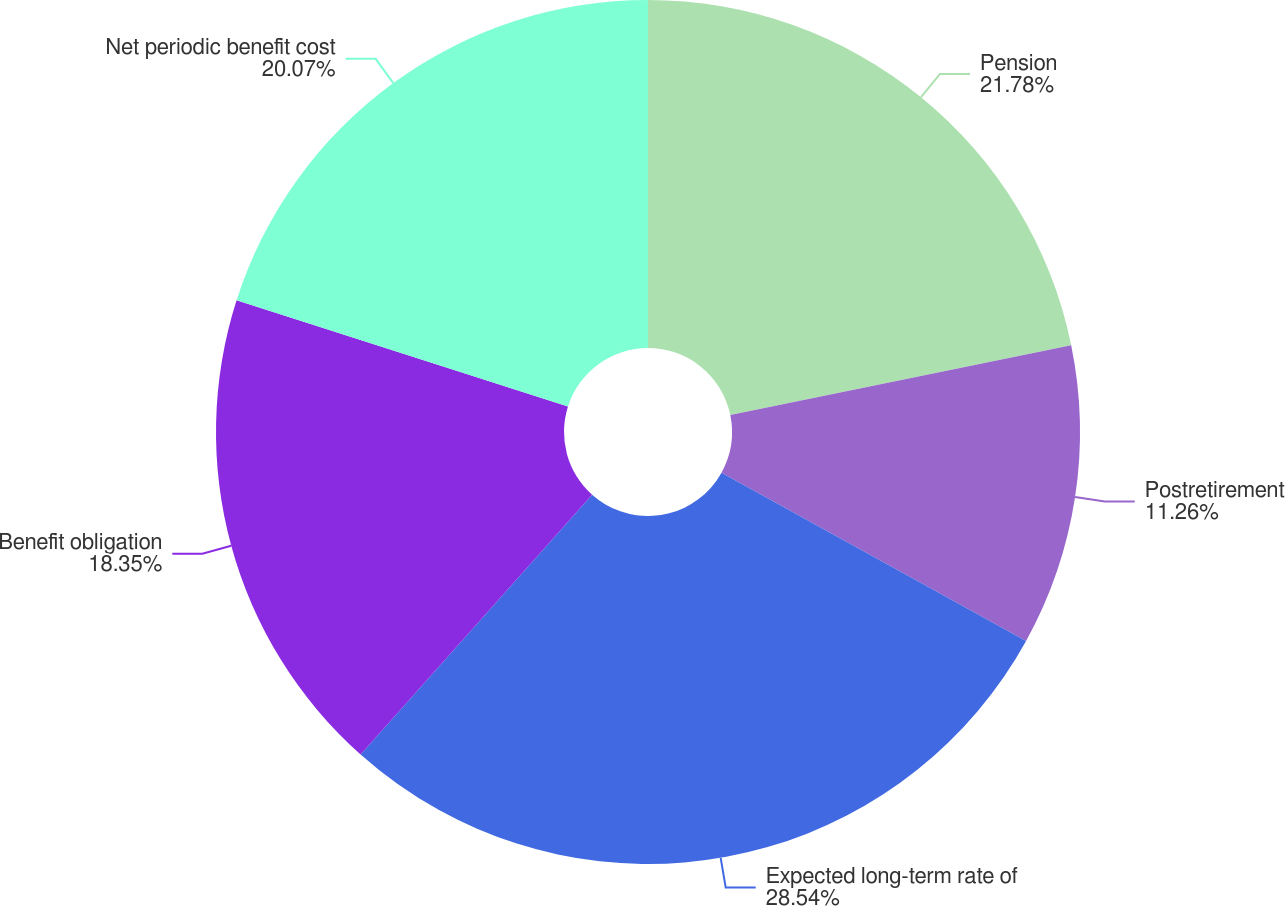<chart> <loc_0><loc_0><loc_500><loc_500><pie_chart><fcel>Pension<fcel>Postretirement<fcel>Expected long-term rate of<fcel>Benefit obligation<fcel>Net periodic benefit cost<nl><fcel>21.78%<fcel>11.26%<fcel>28.55%<fcel>18.35%<fcel>20.07%<nl></chart> 